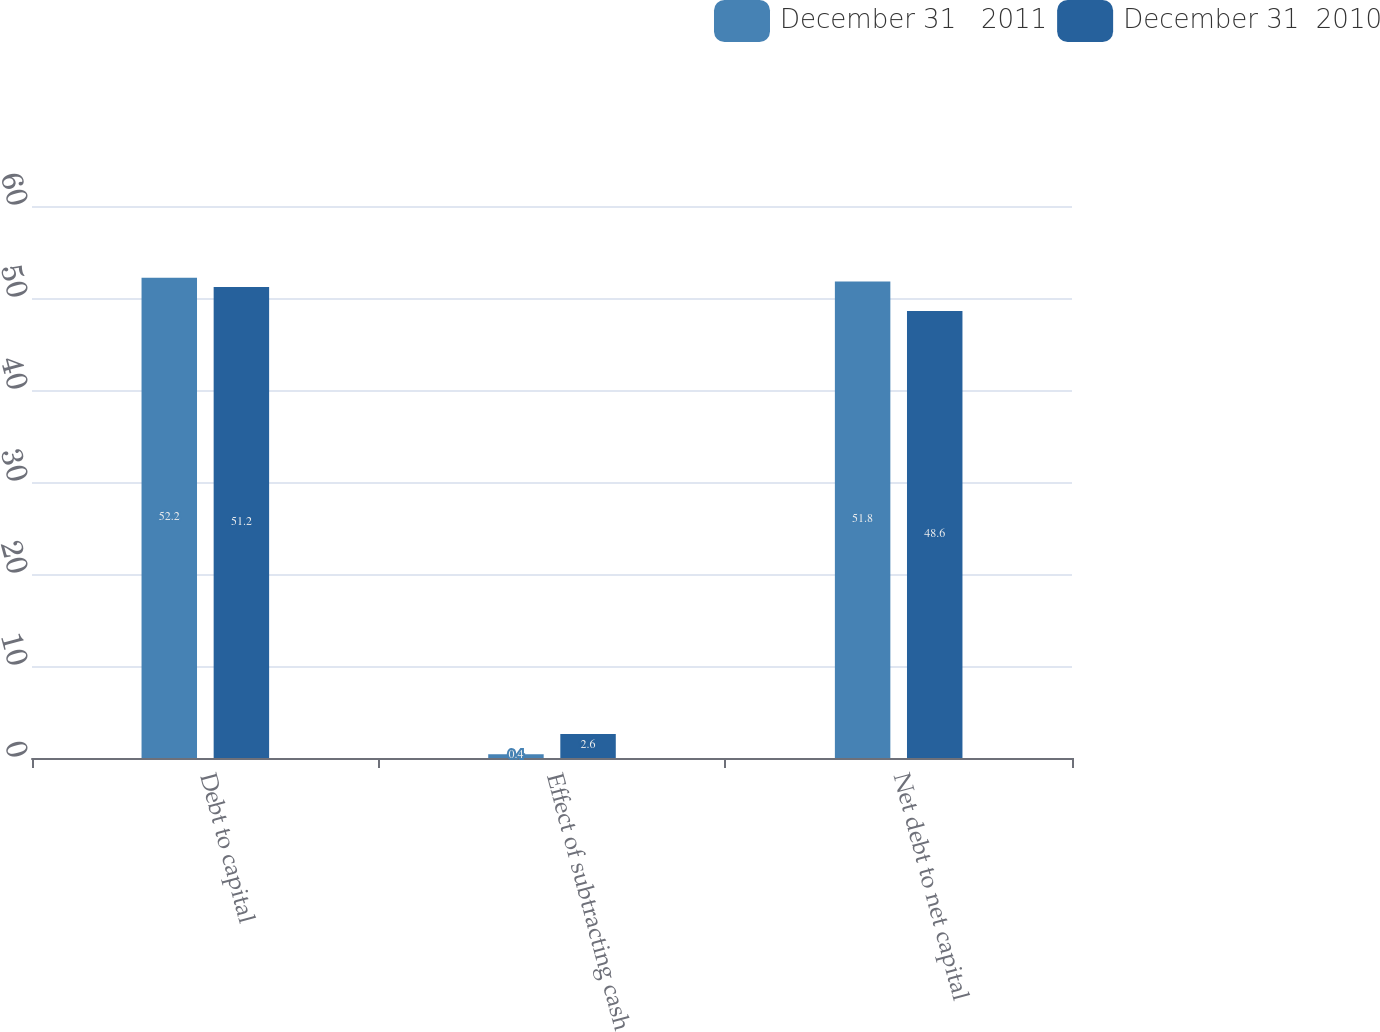Convert chart to OTSL. <chart><loc_0><loc_0><loc_500><loc_500><stacked_bar_chart><ecel><fcel>Debt to capital<fcel>Effect of subtracting cash<fcel>Net debt to net capital<nl><fcel>December 31   2011<fcel>52.2<fcel>0.4<fcel>51.8<nl><fcel>December 31  2010<fcel>51.2<fcel>2.6<fcel>48.6<nl></chart> 